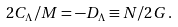<formula> <loc_0><loc_0><loc_500><loc_500>2 C _ { \Lambda } / M = - D _ { \Lambda } \equiv N / 2 G \, .</formula> 